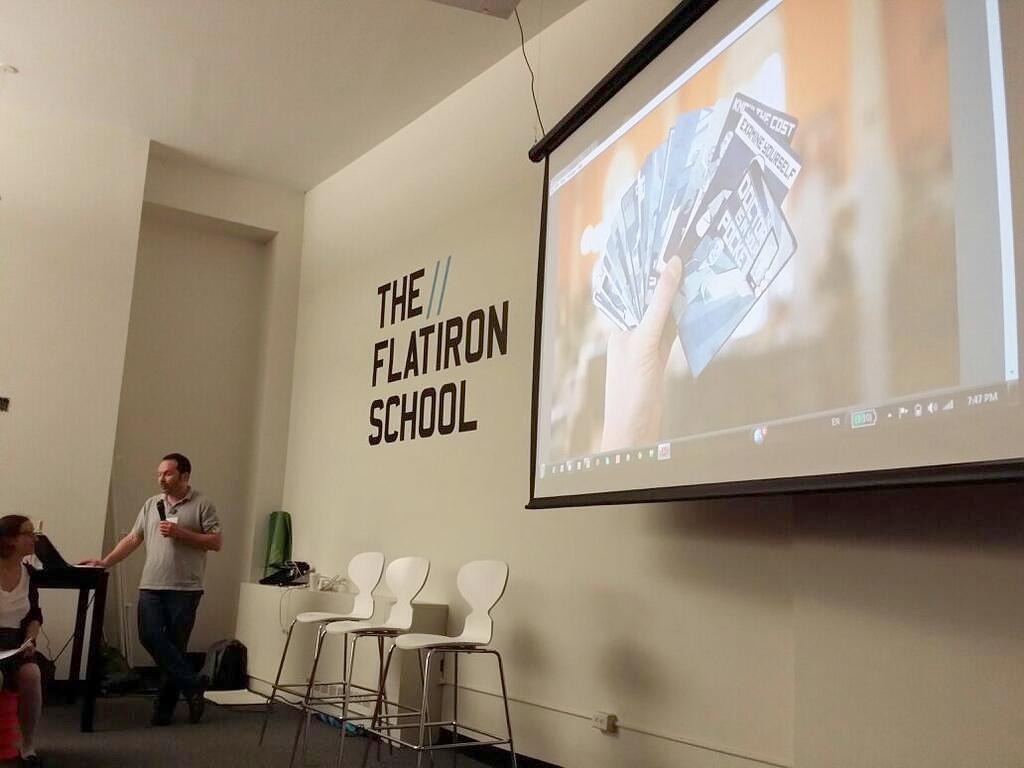What is on the wall in the image? There is a screen on the wall in the image. How many chairs are in the image? There are three chairs in the image. How many people are present in the image? Two people are present in the image. What is one person doing in the image? One person is holding a mic. What is on the floor in the image? There is a bag on the floor in the image. Can you see any chickens in the image? No, there are no chickens present in the image. Are there any ants crawling on the bag on the floor? There is no mention of ants in the image, so we cannot determine if they are present or not. 